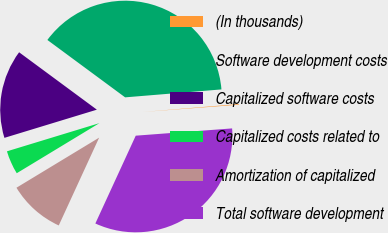Convert chart. <chart><loc_0><loc_0><loc_500><loc_500><pie_chart><fcel>(In thousands)<fcel>Software development costs<fcel>Capitalized software costs<fcel>Capitalized costs related to<fcel>Amortization of capitalized<fcel>Total software development<nl><fcel>0.11%<fcel>38.57%<fcel>14.83%<fcel>3.96%<fcel>9.47%<fcel>33.06%<nl></chart> 